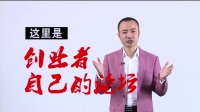The text in the image is in Chinese; what significance might it have, and can it tell us more about the target audience? While I cannot translate the text directly, it's written in Chinese characters, indicating that the image is meant for a Mandarin-speaking audience. The use of calligraphy-style for the red text suggests importance and tradition, implying that the content may be related to topics that hold cultural significance or authority. The presence of such text often signifies an educational or informative message, possibly aiming to inspire or inform viewers. The target audience is likely to be those interested in the subject matter associated with these characters or engaged in a culturally relevant context. 